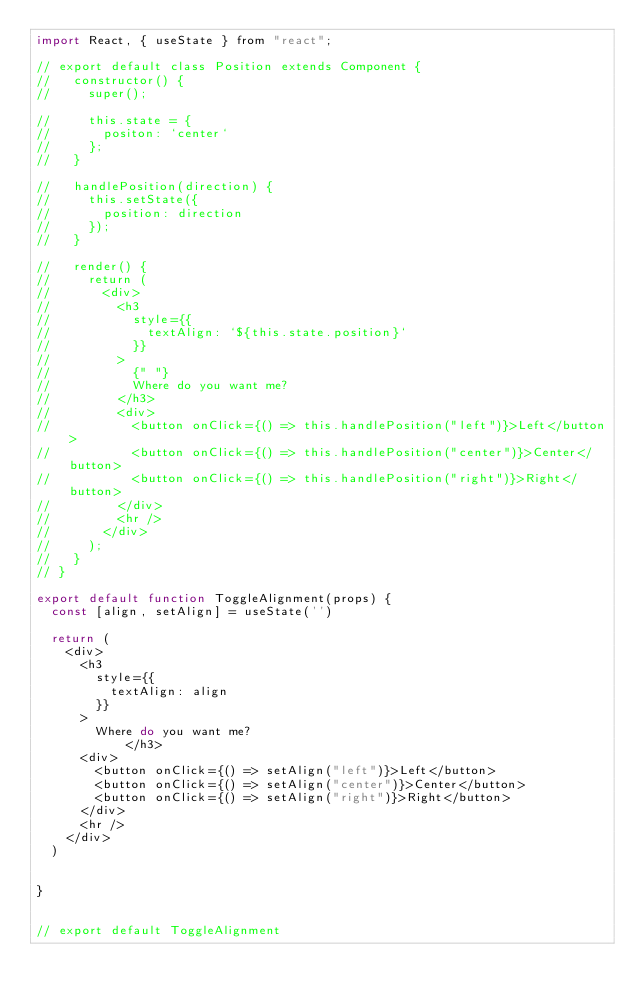<code> <loc_0><loc_0><loc_500><loc_500><_JavaScript_>import React, { useState } from "react";

// export default class Position extends Component {
//   constructor() {
//     super();

//     this.state = {
//       positon: `center`
//     };
//   }

//   handlePosition(direction) {
//     this.setState({
//       position: direction
//     });
//   }

//   render() {
//     return (
//       <div>
//         <h3
//           style={{
//             textAlign: `${this.state.position}`
//           }}
//         >
//           {" "}
//           Where do you want me?
//         </h3>
//         <div>
//           <button onClick={() => this.handlePosition("left")}>Left</button>
//           <button onClick={() => this.handlePosition("center")}>Center</button>
//           <button onClick={() => this.handlePosition("right")}>Right</button>
//         </div>
//         <hr />
//       </div>
//     );
//   }
// }

export default function ToggleAlignment(props) {
  const [align, setAlign] = useState('')

  return (
    <div>
      <h3
        style={{
          textAlign: align
        }}
      >
        Where do you want me?
            </h3>
      <div>
        <button onClick={() => setAlign("left")}>Left</button>
        <button onClick={() => setAlign("center")}>Center</button>
        <button onClick={() => setAlign("right")}>Right</button>
      </div>
      <hr />
    </div>
  )


}


// export default ToggleAlignment</code> 